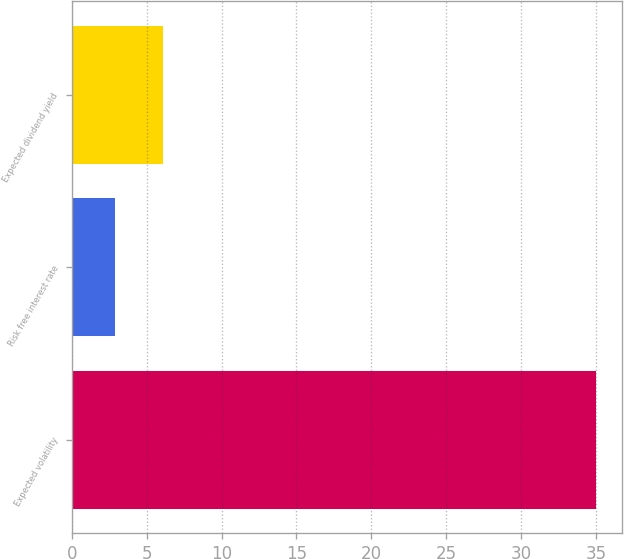<chart> <loc_0><loc_0><loc_500><loc_500><bar_chart><fcel>Expected volatility<fcel>Risk free interest rate<fcel>Expected dividend yield<nl><fcel>35<fcel>2.9<fcel>6.11<nl></chart> 